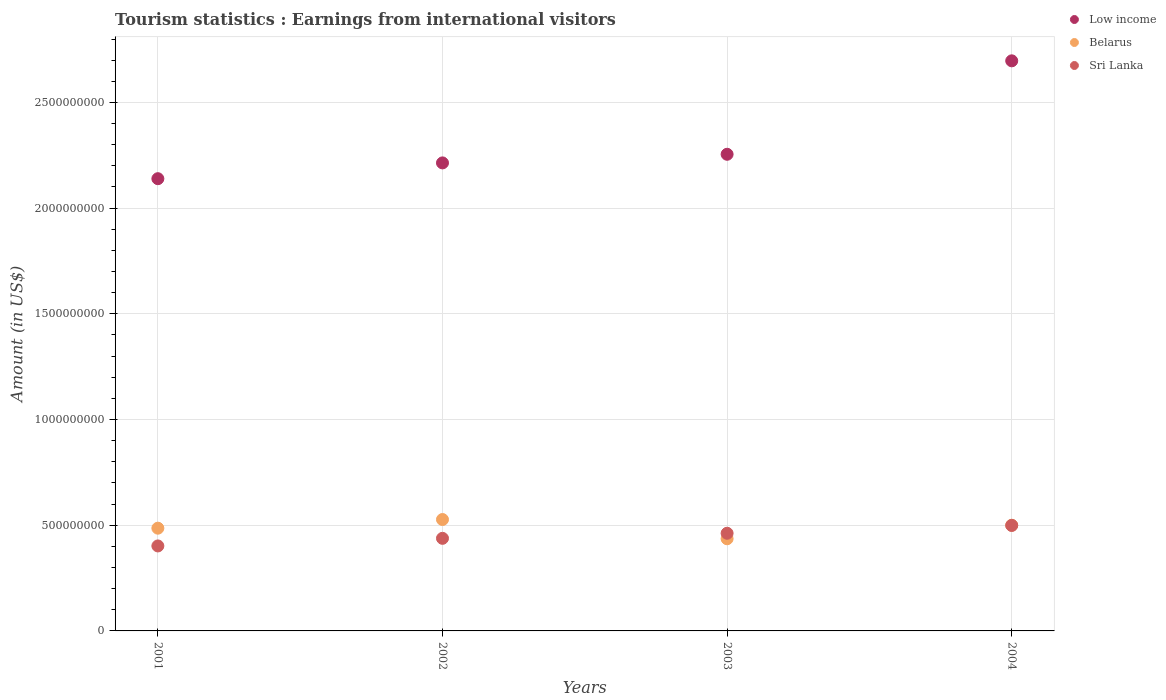How many different coloured dotlines are there?
Make the answer very short. 3. What is the earnings from international visitors in Sri Lanka in 2003?
Make the answer very short. 4.62e+08. Across all years, what is the maximum earnings from international visitors in Belarus?
Your answer should be very brief. 5.27e+08. Across all years, what is the minimum earnings from international visitors in Sri Lanka?
Ensure brevity in your answer.  4.02e+08. In which year was the earnings from international visitors in Low income maximum?
Ensure brevity in your answer.  2004. In which year was the earnings from international visitors in Low income minimum?
Provide a short and direct response. 2001. What is the total earnings from international visitors in Sri Lanka in the graph?
Offer a terse response. 1.80e+09. What is the difference between the earnings from international visitors in Sri Lanka in 2001 and that in 2003?
Ensure brevity in your answer.  -6.00e+07. What is the difference between the earnings from international visitors in Belarus in 2003 and the earnings from international visitors in Low income in 2001?
Provide a short and direct response. -1.70e+09. What is the average earnings from international visitors in Belarus per year?
Provide a short and direct response. 4.87e+08. In the year 2002, what is the difference between the earnings from international visitors in Low income and earnings from international visitors in Belarus?
Your answer should be compact. 1.69e+09. In how many years, is the earnings from international visitors in Belarus greater than 1400000000 US$?
Ensure brevity in your answer.  0. What is the ratio of the earnings from international visitors in Sri Lanka in 2002 to that in 2003?
Make the answer very short. 0.95. Is the difference between the earnings from international visitors in Low income in 2001 and 2003 greater than the difference between the earnings from international visitors in Belarus in 2001 and 2003?
Provide a succinct answer. No. What is the difference between the highest and the second highest earnings from international visitors in Low income?
Provide a short and direct response. 4.42e+08. What is the difference between the highest and the lowest earnings from international visitors in Low income?
Your response must be concise. 5.58e+08. Does the earnings from international visitors in Low income monotonically increase over the years?
Make the answer very short. Yes. Is the earnings from international visitors in Belarus strictly greater than the earnings from international visitors in Sri Lanka over the years?
Your answer should be compact. No. Is the earnings from international visitors in Belarus strictly less than the earnings from international visitors in Sri Lanka over the years?
Offer a very short reply. No. How many dotlines are there?
Provide a succinct answer. 3. Does the graph contain any zero values?
Offer a very short reply. No. How many legend labels are there?
Ensure brevity in your answer.  3. What is the title of the graph?
Give a very brief answer. Tourism statistics : Earnings from international visitors. What is the Amount (in US$) of Low income in 2001?
Give a very brief answer. 2.14e+09. What is the Amount (in US$) of Belarus in 2001?
Make the answer very short. 4.86e+08. What is the Amount (in US$) in Sri Lanka in 2001?
Give a very brief answer. 4.02e+08. What is the Amount (in US$) in Low income in 2002?
Your answer should be very brief. 2.21e+09. What is the Amount (in US$) of Belarus in 2002?
Your answer should be compact. 5.27e+08. What is the Amount (in US$) in Sri Lanka in 2002?
Offer a very short reply. 4.38e+08. What is the Amount (in US$) in Low income in 2003?
Offer a very short reply. 2.25e+09. What is the Amount (in US$) in Belarus in 2003?
Your response must be concise. 4.36e+08. What is the Amount (in US$) of Sri Lanka in 2003?
Keep it short and to the point. 4.62e+08. What is the Amount (in US$) of Low income in 2004?
Ensure brevity in your answer.  2.70e+09. What is the Amount (in US$) of Belarus in 2004?
Your response must be concise. 5.00e+08. What is the Amount (in US$) of Sri Lanka in 2004?
Offer a very short reply. 4.99e+08. Across all years, what is the maximum Amount (in US$) of Low income?
Offer a terse response. 2.70e+09. Across all years, what is the maximum Amount (in US$) of Belarus?
Your answer should be very brief. 5.27e+08. Across all years, what is the maximum Amount (in US$) in Sri Lanka?
Make the answer very short. 4.99e+08. Across all years, what is the minimum Amount (in US$) of Low income?
Your answer should be compact. 2.14e+09. Across all years, what is the minimum Amount (in US$) in Belarus?
Ensure brevity in your answer.  4.36e+08. Across all years, what is the minimum Amount (in US$) of Sri Lanka?
Offer a very short reply. 4.02e+08. What is the total Amount (in US$) in Low income in the graph?
Your answer should be very brief. 9.30e+09. What is the total Amount (in US$) of Belarus in the graph?
Your response must be concise. 1.95e+09. What is the total Amount (in US$) in Sri Lanka in the graph?
Offer a very short reply. 1.80e+09. What is the difference between the Amount (in US$) of Low income in 2001 and that in 2002?
Your response must be concise. -7.47e+07. What is the difference between the Amount (in US$) of Belarus in 2001 and that in 2002?
Give a very brief answer. -4.10e+07. What is the difference between the Amount (in US$) in Sri Lanka in 2001 and that in 2002?
Offer a very short reply. -3.60e+07. What is the difference between the Amount (in US$) of Low income in 2001 and that in 2003?
Ensure brevity in your answer.  -1.15e+08. What is the difference between the Amount (in US$) in Sri Lanka in 2001 and that in 2003?
Your answer should be compact. -6.00e+07. What is the difference between the Amount (in US$) in Low income in 2001 and that in 2004?
Offer a terse response. -5.58e+08. What is the difference between the Amount (in US$) in Belarus in 2001 and that in 2004?
Keep it short and to the point. -1.40e+07. What is the difference between the Amount (in US$) in Sri Lanka in 2001 and that in 2004?
Provide a succinct answer. -9.70e+07. What is the difference between the Amount (in US$) in Low income in 2002 and that in 2003?
Your answer should be compact. -4.08e+07. What is the difference between the Amount (in US$) of Belarus in 2002 and that in 2003?
Provide a short and direct response. 9.10e+07. What is the difference between the Amount (in US$) of Sri Lanka in 2002 and that in 2003?
Offer a terse response. -2.40e+07. What is the difference between the Amount (in US$) of Low income in 2002 and that in 2004?
Keep it short and to the point. -4.83e+08. What is the difference between the Amount (in US$) of Belarus in 2002 and that in 2004?
Offer a very short reply. 2.70e+07. What is the difference between the Amount (in US$) of Sri Lanka in 2002 and that in 2004?
Provide a short and direct response. -6.10e+07. What is the difference between the Amount (in US$) of Low income in 2003 and that in 2004?
Your response must be concise. -4.42e+08. What is the difference between the Amount (in US$) in Belarus in 2003 and that in 2004?
Give a very brief answer. -6.40e+07. What is the difference between the Amount (in US$) of Sri Lanka in 2003 and that in 2004?
Your answer should be very brief. -3.70e+07. What is the difference between the Amount (in US$) of Low income in 2001 and the Amount (in US$) of Belarus in 2002?
Make the answer very short. 1.61e+09. What is the difference between the Amount (in US$) of Low income in 2001 and the Amount (in US$) of Sri Lanka in 2002?
Your answer should be very brief. 1.70e+09. What is the difference between the Amount (in US$) of Belarus in 2001 and the Amount (in US$) of Sri Lanka in 2002?
Your answer should be very brief. 4.80e+07. What is the difference between the Amount (in US$) in Low income in 2001 and the Amount (in US$) in Belarus in 2003?
Your answer should be compact. 1.70e+09. What is the difference between the Amount (in US$) in Low income in 2001 and the Amount (in US$) in Sri Lanka in 2003?
Provide a succinct answer. 1.68e+09. What is the difference between the Amount (in US$) of Belarus in 2001 and the Amount (in US$) of Sri Lanka in 2003?
Offer a very short reply. 2.40e+07. What is the difference between the Amount (in US$) of Low income in 2001 and the Amount (in US$) of Belarus in 2004?
Your answer should be compact. 1.64e+09. What is the difference between the Amount (in US$) in Low income in 2001 and the Amount (in US$) in Sri Lanka in 2004?
Provide a short and direct response. 1.64e+09. What is the difference between the Amount (in US$) of Belarus in 2001 and the Amount (in US$) of Sri Lanka in 2004?
Offer a terse response. -1.30e+07. What is the difference between the Amount (in US$) of Low income in 2002 and the Amount (in US$) of Belarus in 2003?
Offer a terse response. 1.78e+09. What is the difference between the Amount (in US$) of Low income in 2002 and the Amount (in US$) of Sri Lanka in 2003?
Your answer should be very brief. 1.75e+09. What is the difference between the Amount (in US$) of Belarus in 2002 and the Amount (in US$) of Sri Lanka in 2003?
Make the answer very short. 6.50e+07. What is the difference between the Amount (in US$) in Low income in 2002 and the Amount (in US$) in Belarus in 2004?
Your response must be concise. 1.71e+09. What is the difference between the Amount (in US$) of Low income in 2002 and the Amount (in US$) of Sri Lanka in 2004?
Provide a short and direct response. 1.72e+09. What is the difference between the Amount (in US$) in Belarus in 2002 and the Amount (in US$) in Sri Lanka in 2004?
Your answer should be very brief. 2.80e+07. What is the difference between the Amount (in US$) of Low income in 2003 and the Amount (in US$) of Belarus in 2004?
Offer a very short reply. 1.75e+09. What is the difference between the Amount (in US$) of Low income in 2003 and the Amount (in US$) of Sri Lanka in 2004?
Offer a very short reply. 1.76e+09. What is the difference between the Amount (in US$) of Belarus in 2003 and the Amount (in US$) of Sri Lanka in 2004?
Make the answer very short. -6.30e+07. What is the average Amount (in US$) in Low income per year?
Your answer should be compact. 2.33e+09. What is the average Amount (in US$) of Belarus per year?
Keep it short and to the point. 4.87e+08. What is the average Amount (in US$) in Sri Lanka per year?
Provide a succinct answer. 4.50e+08. In the year 2001, what is the difference between the Amount (in US$) of Low income and Amount (in US$) of Belarus?
Provide a succinct answer. 1.65e+09. In the year 2001, what is the difference between the Amount (in US$) in Low income and Amount (in US$) in Sri Lanka?
Keep it short and to the point. 1.74e+09. In the year 2001, what is the difference between the Amount (in US$) in Belarus and Amount (in US$) in Sri Lanka?
Your answer should be compact. 8.40e+07. In the year 2002, what is the difference between the Amount (in US$) in Low income and Amount (in US$) in Belarus?
Provide a short and direct response. 1.69e+09. In the year 2002, what is the difference between the Amount (in US$) in Low income and Amount (in US$) in Sri Lanka?
Provide a succinct answer. 1.78e+09. In the year 2002, what is the difference between the Amount (in US$) of Belarus and Amount (in US$) of Sri Lanka?
Your answer should be compact. 8.90e+07. In the year 2003, what is the difference between the Amount (in US$) in Low income and Amount (in US$) in Belarus?
Your answer should be very brief. 1.82e+09. In the year 2003, what is the difference between the Amount (in US$) of Low income and Amount (in US$) of Sri Lanka?
Provide a short and direct response. 1.79e+09. In the year 2003, what is the difference between the Amount (in US$) of Belarus and Amount (in US$) of Sri Lanka?
Provide a succinct answer. -2.60e+07. In the year 2004, what is the difference between the Amount (in US$) in Low income and Amount (in US$) in Belarus?
Make the answer very short. 2.20e+09. In the year 2004, what is the difference between the Amount (in US$) in Low income and Amount (in US$) in Sri Lanka?
Your answer should be very brief. 2.20e+09. In the year 2004, what is the difference between the Amount (in US$) in Belarus and Amount (in US$) in Sri Lanka?
Your answer should be compact. 1.00e+06. What is the ratio of the Amount (in US$) in Low income in 2001 to that in 2002?
Your answer should be very brief. 0.97. What is the ratio of the Amount (in US$) of Belarus in 2001 to that in 2002?
Provide a succinct answer. 0.92. What is the ratio of the Amount (in US$) in Sri Lanka in 2001 to that in 2002?
Offer a very short reply. 0.92. What is the ratio of the Amount (in US$) in Low income in 2001 to that in 2003?
Your answer should be very brief. 0.95. What is the ratio of the Amount (in US$) in Belarus in 2001 to that in 2003?
Your answer should be compact. 1.11. What is the ratio of the Amount (in US$) of Sri Lanka in 2001 to that in 2003?
Offer a terse response. 0.87. What is the ratio of the Amount (in US$) in Low income in 2001 to that in 2004?
Offer a very short reply. 0.79. What is the ratio of the Amount (in US$) of Belarus in 2001 to that in 2004?
Your answer should be compact. 0.97. What is the ratio of the Amount (in US$) in Sri Lanka in 2001 to that in 2004?
Your answer should be compact. 0.81. What is the ratio of the Amount (in US$) of Low income in 2002 to that in 2003?
Provide a succinct answer. 0.98. What is the ratio of the Amount (in US$) of Belarus in 2002 to that in 2003?
Provide a succinct answer. 1.21. What is the ratio of the Amount (in US$) in Sri Lanka in 2002 to that in 2003?
Offer a very short reply. 0.95. What is the ratio of the Amount (in US$) of Low income in 2002 to that in 2004?
Your answer should be compact. 0.82. What is the ratio of the Amount (in US$) in Belarus in 2002 to that in 2004?
Your answer should be compact. 1.05. What is the ratio of the Amount (in US$) of Sri Lanka in 2002 to that in 2004?
Ensure brevity in your answer.  0.88. What is the ratio of the Amount (in US$) in Low income in 2003 to that in 2004?
Make the answer very short. 0.84. What is the ratio of the Amount (in US$) in Belarus in 2003 to that in 2004?
Keep it short and to the point. 0.87. What is the ratio of the Amount (in US$) in Sri Lanka in 2003 to that in 2004?
Provide a short and direct response. 0.93. What is the difference between the highest and the second highest Amount (in US$) in Low income?
Ensure brevity in your answer.  4.42e+08. What is the difference between the highest and the second highest Amount (in US$) in Belarus?
Offer a very short reply. 2.70e+07. What is the difference between the highest and the second highest Amount (in US$) in Sri Lanka?
Give a very brief answer. 3.70e+07. What is the difference between the highest and the lowest Amount (in US$) in Low income?
Your answer should be very brief. 5.58e+08. What is the difference between the highest and the lowest Amount (in US$) in Belarus?
Keep it short and to the point. 9.10e+07. What is the difference between the highest and the lowest Amount (in US$) of Sri Lanka?
Ensure brevity in your answer.  9.70e+07. 